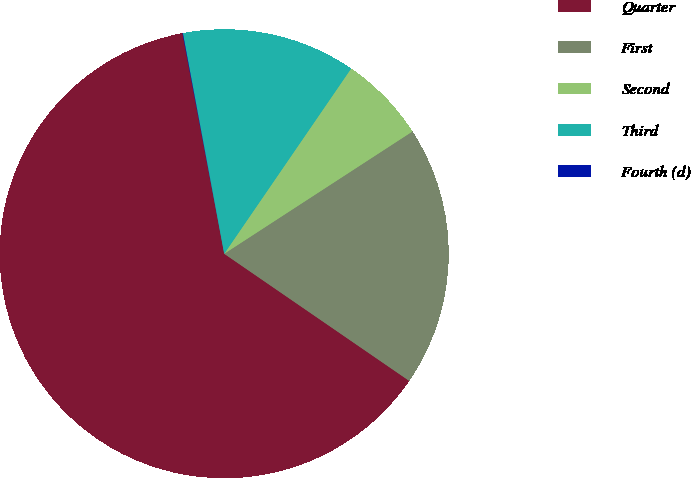Convert chart. <chart><loc_0><loc_0><loc_500><loc_500><pie_chart><fcel>Quarter<fcel>First<fcel>Second<fcel>Third<fcel>Fourth (d)<nl><fcel>62.44%<fcel>18.75%<fcel>6.27%<fcel>12.51%<fcel>0.03%<nl></chart> 